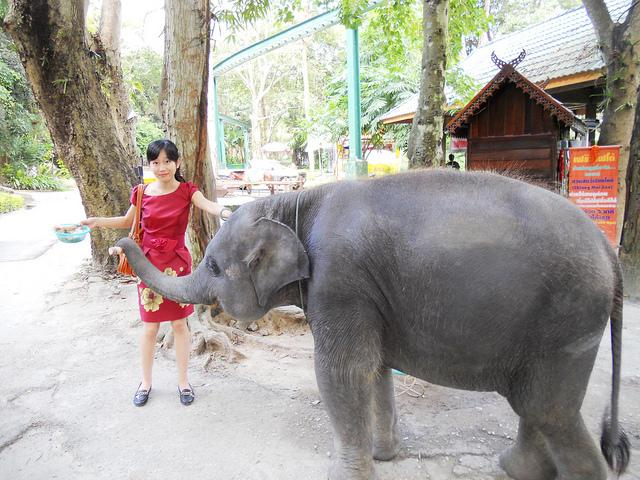What does the elephant here seek? food 